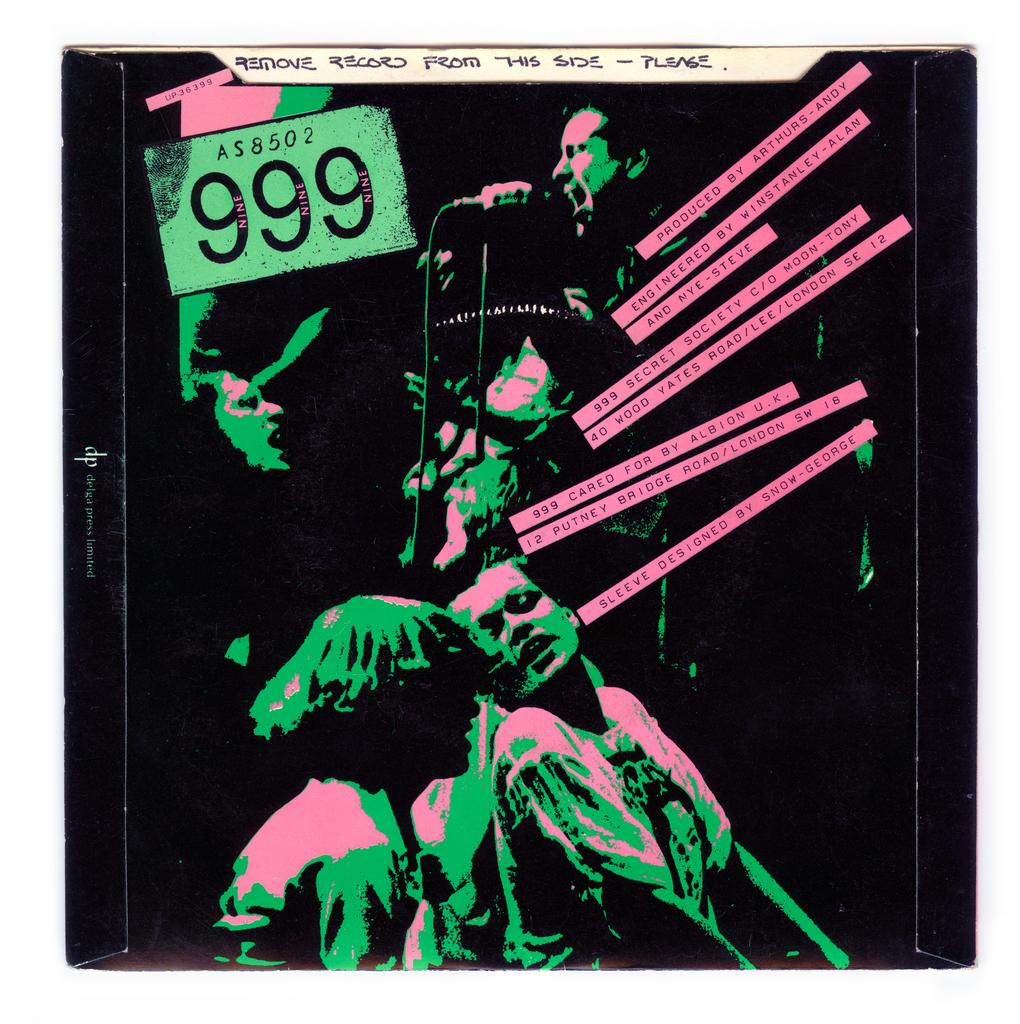Which side should you remove the record from?
Your answer should be compact. This side. Is 999 a musical band?
Your response must be concise. Yes. 